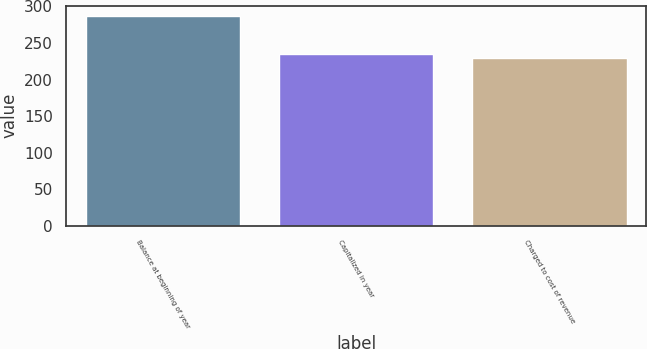Convert chart. <chart><loc_0><loc_0><loc_500><loc_500><bar_chart><fcel>Balance at beginning of year<fcel>Capitalized in year<fcel>Charged to cost of revenue<nl><fcel>287<fcel>234.8<fcel>229<nl></chart> 